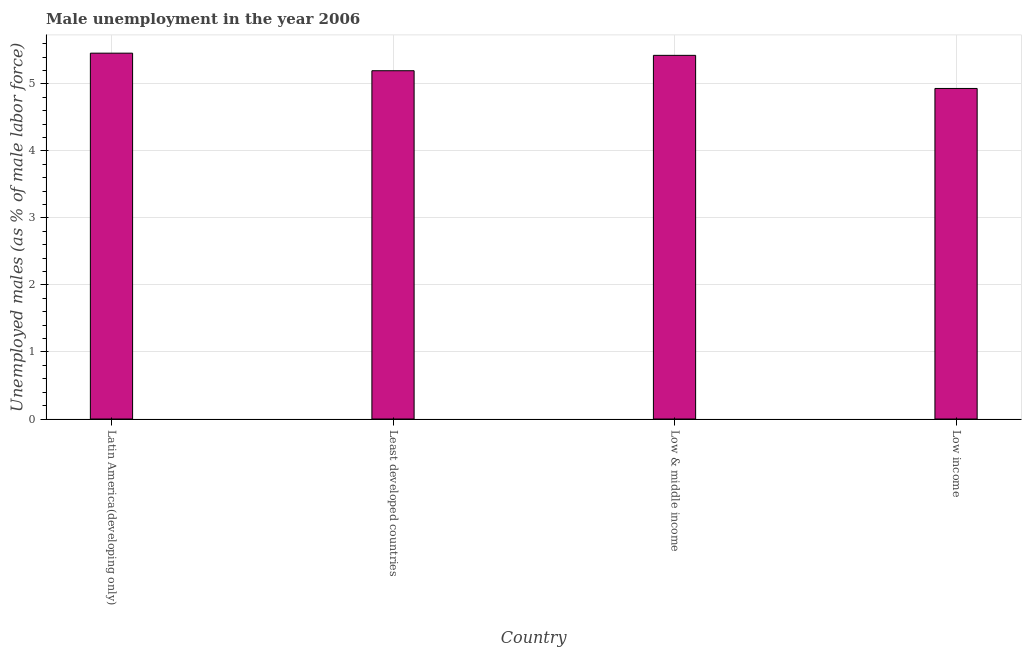Does the graph contain grids?
Your response must be concise. Yes. What is the title of the graph?
Offer a terse response. Male unemployment in the year 2006. What is the label or title of the Y-axis?
Keep it short and to the point. Unemployed males (as % of male labor force). What is the unemployed males population in Low & middle income?
Offer a terse response. 5.43. Across all countries, what is the maximum unemployed males population?
Ensure brevity in your answer.  5.46. Across all countries, what is the minimum unemployed males population?
Offer a terse response. 4.93. In which country was the unemployed males population maximum?
Make the answer very short. Latin America(developing only). In which country was the unemployed males population minimum?
Make the answer very short. Low income. What is the sum of the unemployed males population?
Offer a terse response. 21.01. What is the difference between the unemployed males population in Least developed countries and Low & middle income?
Your answer should be compact. -0.23. What is the average unemployed males population per country?
Offer a very short reply. 5.25. What is the median unemployed males population?
Your answer should be compact. 5.31. In how many countries, is the unemployed males population greater than 0.4 %?
Your answer should be compact. 4. What is the ratio of the unemployed males population in Latin America(developing only) to that in Low & middle income?
Offer a very short reply. 1.01. Is the difference between the unemployed males population in Latin America(developing only) and Low & middle income greater than the difference between any two countries?
Offer a terse response. No. What is the difference between the highest and the second highest unemployed males population?
Give a very brief answer. 0.03. Is the sum of the unemployed males population in Low & middle income and Low income greater than the maximum unemployed males population across all countries?
Provide a succinct answer. Yes. What is the difference between the highest and the lowest unemployed males population?
Your answer should be very brief. 0.53. In how many countries, is the unemployed males population greater than the average unemployed males population taken over all countries?
Offer a very short reply. 2. How many bars are there?
Give a very brief answer. 4. Are the values on the major ticks of Y-axis written in scientific E-notation?
Your answer should be compact. No. What is the Unemployed males (as % of male labor force) in Latin America(developing only)?
Offer a very short reply. 5.46. What is the Unemployed males (as % of male labor force) in Least developed countries?
Your response must be concise. 5.2. What is the Unemployed males (as % of male labor force) of Low & middle income?
Keep it short and to the point. 5.43. What is the Unemployed males (as % of male labor force) of Low income?
Your response must be concise. 4.93. What is the difference between the Unemployed males (as % of male labor force) in Latin America(developing only) and Least developed countries?
Give a very brief answer. 0.26. What is the difference between the Unemployed males (as % of male labor force) in Latin America(developing only) and Low & middle income?
Provide a short and direct response. 0.03. What is the difference between the Unemployed males (as % of male labor force) in Latin America(developing only) and Low income?
Your answer should be compact. 0.53. What is the difference between the Unemployed males (as % of male labor force) in Least developed countries and Low & middle income?
Ensure brevity in your answer.  -0.23. What is the difference between the Unemployed males (as % of male labor force) in Least developed countries and Low income?
Offer a very short reply. 0.26. What is the difference between the Unemployed males (as % of male labor force) in Low & middle income and Low income?
Provide a short and direct response. 0.49. What is the ratio of the Unemployed males (as % of male labor force) in Latin America(developing only) to that in Low income?
Provide a succinct answer. 1.11. What is the ratio of the Unemployed males (as % of male labor force) in Least developed countries to that in Low & middle income?
Provide a succinct answer. 0.96. What is the ratio of the Unemployed males (as % of male labor force) in Least developed countries to that in Low income?
Provide a short and direct response. 1.05. 